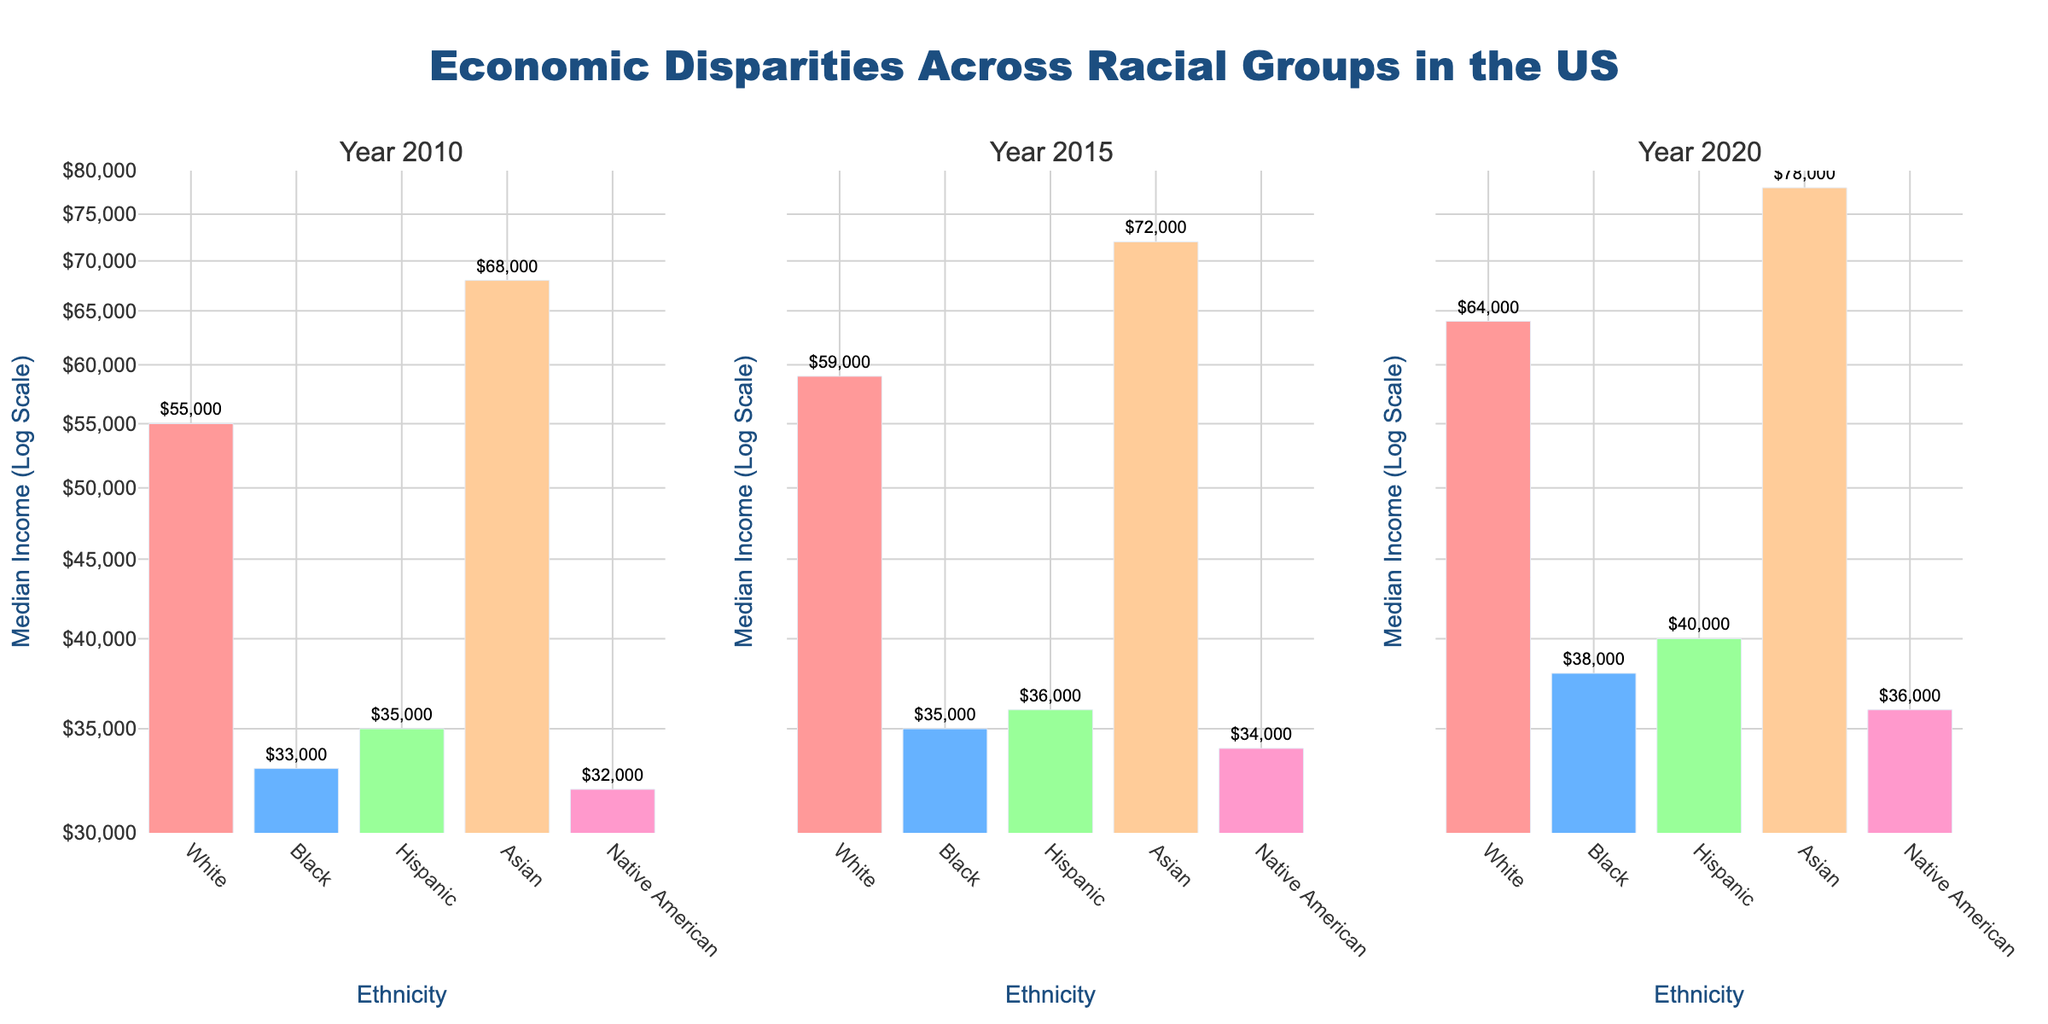What is the overall title of the figure? The overall title of the figure is typically situated at the top center and gives a summary of what the figure is about. In this case, the title is "Economic Disparities Across Racial Groups in the US." This is mentioned as it describes the content of the subplots.
Answer: Economic Disparities Across Racial Groups in the US In which year did the Asian ethnic group have the highest median income? To determine this, we need to look at the height of the bars for the Asian ethnic group across all the years (2010, 2015, 2020). The bar for the year 2020 is the tallest, indicating it had the highest median income of $78,000.
Answer: 2020 Compare the median income of the Black and Hispanic ethnic groups in 2015. Which one is higher? We need to compare the heights of the bars for the Black and Hispanic ethnic groups in 2015. The bar for the Hispanic ethnic group is slightly taller than that for the Black ethnic group, indicating a higher median income of $36,000 compared to $35,000.
Answer: Hispanic What is the range of the y-axis in the figure? The y-axis is set to a log scale. By examining the axis labels and ticks, we see that the range spans from around 30,000 to 80,000 in terms of median income dollars.
Answer: 30,000 to 80,000 Identify the ethnic group with the lowest median income in 2010. To find this, we need to identify the shortest bar in the 2010 subplot. The Native American ethnic group has the shortest bar, indicating the lowest median income of $32,000.
Answer: Native American How did the median income of the White ethnic group change from 2015 to 2020? By comparing the height of the bars for the White ethnic group between 2015 and 2020, we see that the median income increased from $59,000 to $64,000.
Answer: Increased by $5,000 What is the median income for the Hispanic ethnic group in 2020? We locate the height of the bar for the Hispanic ethnic group in the 2020 subplot. The value at the top of the bar and the text label both indicate a median income of $40,000.
Answer: $40,000 Which ethnic group shows the largest increase in median income from 2010 to 2020? By comparing the height difference of bars from 2010 to 2020 for each ethnic group, the Asian ethnic group shows the largest increase from $68,000 to $78,000, which is a $10,000 increase.
Answer: Asian Which ethnic group had a lower median income than the Hispanic group in 2010 and again in 2020? By comparing the bars for each ethnic group with the Hispanic group's bar in the years 2010 and 2020, both the Black and Native American groups had lower median incomes in these years. But only Native American consistently had a lower median income than the Hispanic group in both years.
Answer: Native American 